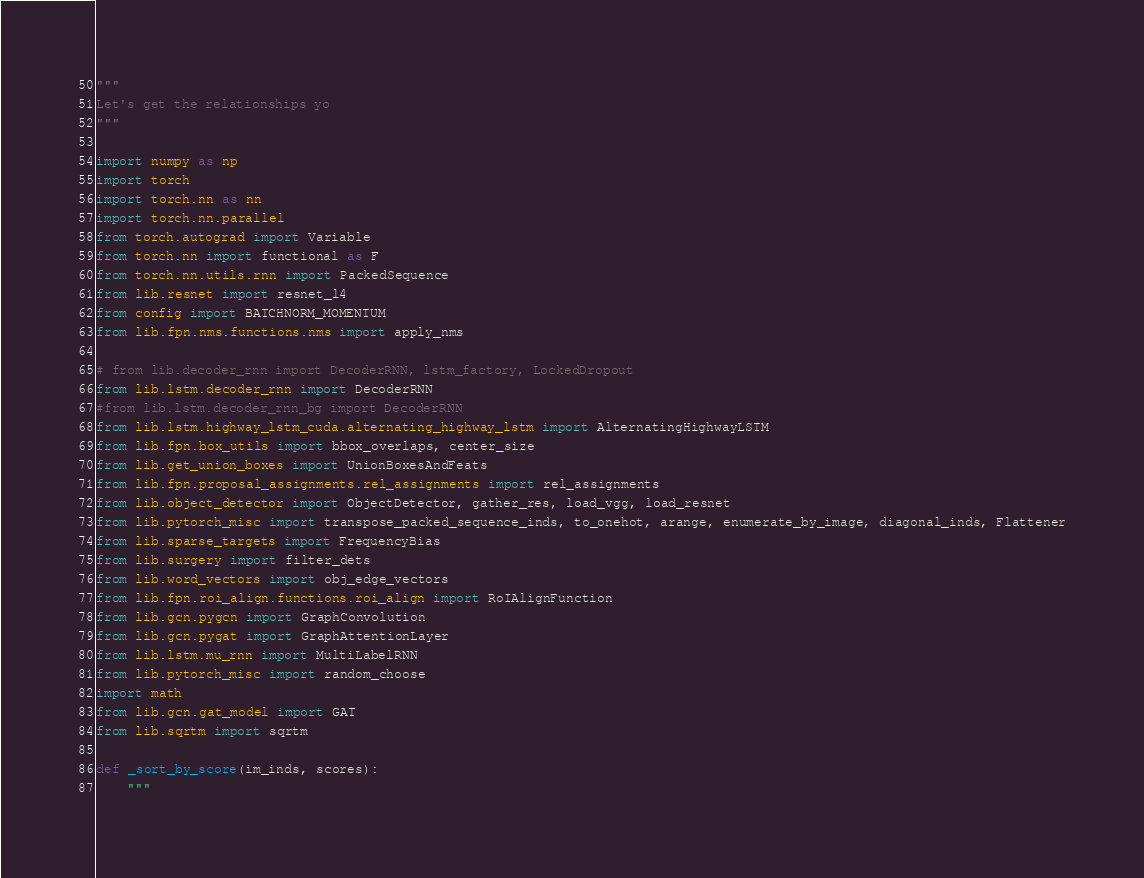<code> <loc_0><loc_0><loc_500><loc_500><_Python_>"""
Let's get the relationships yo
"""

import numpy as np
import torch
import torch.nn as nn
import torch.nn.parallel
from torch.autograd import Variable
from torch.nn import functional as F
from torch.nn.utils.rnn import PackedSequence
from lib.resnet import resnet_l4
from config import BATCHNORM_MOMENTUM
from lib.fpn.nms.functions.nms import apply_nms

# from lib.decoder_rnn import DecoderRNN, lstm_factory, LockedDropout
from lib.lstm.decoder_rnn import DecoderRNN
#from lib.lstm.decoder_rnn_bg import DecoderRNN
from lib.lstm.highway_lstm_cuda.alternating_highway_lstm import AlternatingHighwayLSTM
from lib.fpn.box_utils import bbox_overlaps, center_size
from lib.get_union_boxes import UnionBoxesAndFeats
from lib.fpn.proposal_assignments.rel_assignments import rel_assignments
from lib.object_detector import ObjectDetector, gather_res, load_vgg, load_resnet
from lib.pytorch_misc import transpose_packed_sequence_inds, to_onehot, arange, enumerate_by_image, diagonal_inds, Flattener
from lib.sparse_targets import FrequencyBias
from lib.surgery import filter_dets
from lib.word_vectors import obj_edge_vectors
from lib.fpn.roi_align.functions.roi_align import RoIAlignFunction
from lib.gcn.pygcn import GraphConvolution
from lib.gcn.pygat import GraphAttentionLayer
from lib.lstm.mu_rnn import MultiLabelRNN
from lib.pytorch_misc import random_choose
import math
from lib.gcn.gat_model import GAT
from lib.sqrtm import sqrtm

def _sort_by_score(im_inds, scores):
    """</code> 